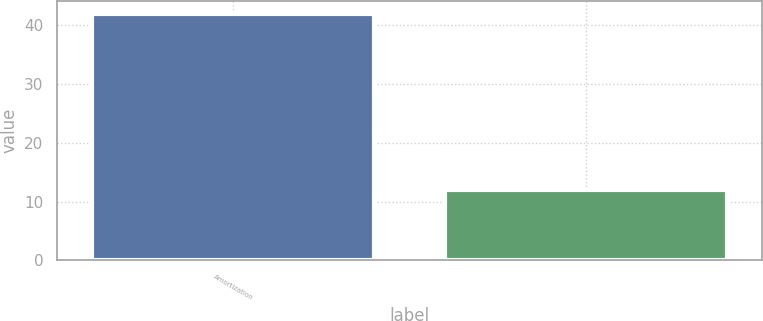Convert chart to OTSL. <chart><loc_0><loc_0><loc_500><loc_500><bar_chart><fcel>Amortization<fcel>Unnamed: 1<nl><fcel>42<fcel>12<nl></chart> 